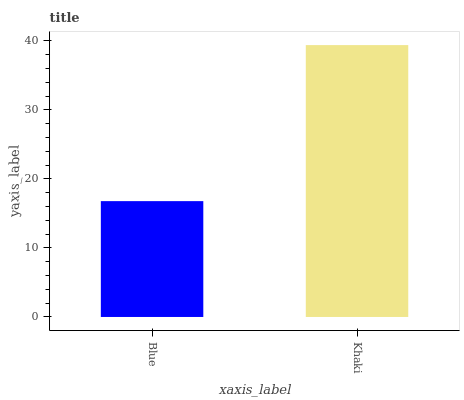Is Blue the minimum?
Answer yes or no. Yes. Is Khaki the maximum?
Answer yes or no. Yes. Is Khaki the minimum?
Answer yes or no. No. Is Khaki greater than Blue?
Answer yes or no. Yes. Is Blue less than Khaki?
Answer yes or no. Yes. Is Blue greater than Khaki?
Answer yes or no. No. Is Khaki less than Blue?
Answer yes or no. No. Is Khaki the high median?
Answer yes or no. Yes. Is Blue the low median?
Answer yes or no. Yes. Is Blue the high median?
Answer yes or no. No. Is Khaki the low median?
Answer yes or no. No. 